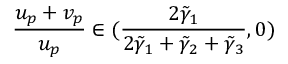Convert formula to latex. <formula><loc_0><loc_0><loc_500><loc_500>\frac { u _ { p } + v _ { p } } { u _ { p } } \in ( \frac { 2 \tilde { \gamma } _ { 1 } } { 2 \tilde { \gamma } _ { 1 } + \tilde { \gamma } _ { 2 } + \tilde { \gamma } _ { 3 } } , 0 )</formula> 